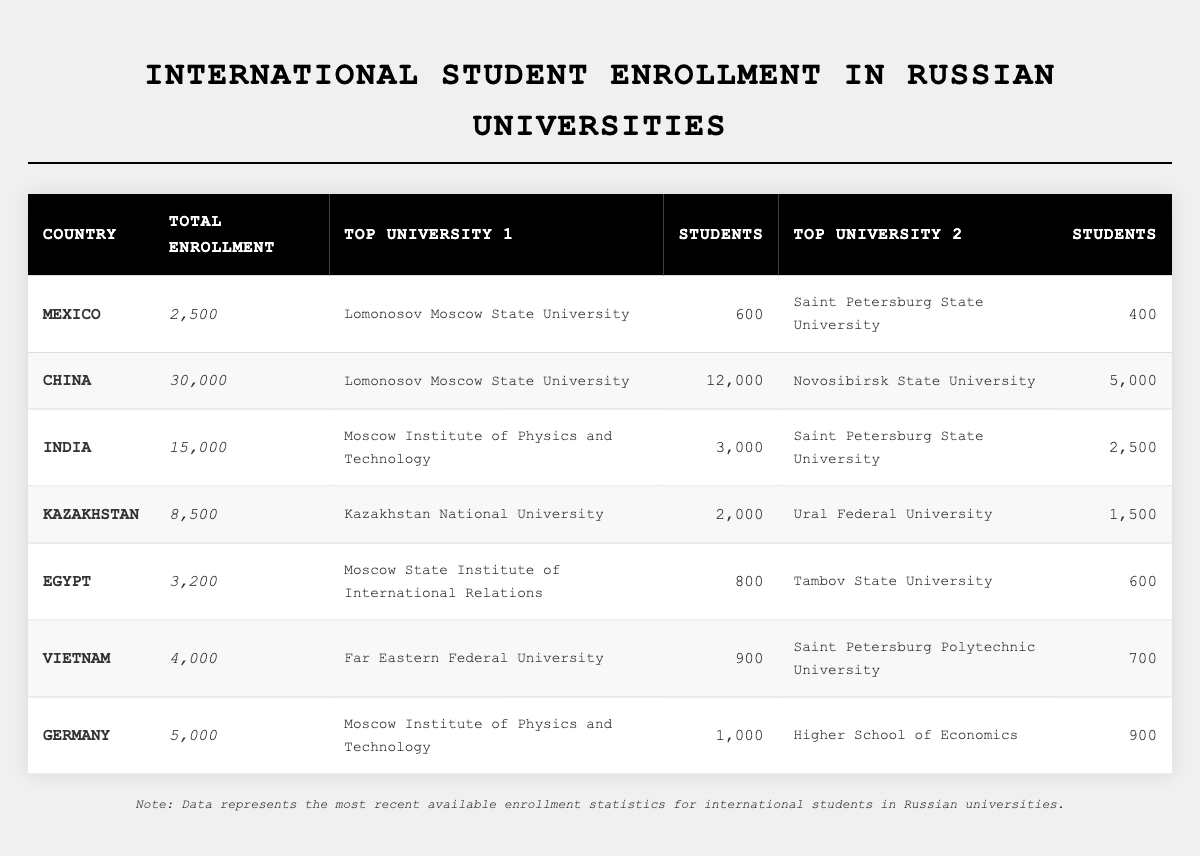What country has the highest number of international students enrolled in Russian universities? The table shows that China has the highest enrollment with 30,000 students.
Answer: China How many students are enrolled from Mexico? According to the table, Mexico has an enrollment of 2,500 international students.
Answer: 2,500 Which two universities enroll the most students from India? The top two universities for Indian students are Moscow Institute of Physics and Technology with 3,000 students and Saint Petersburg State University with 2,500 students.
Answer: Moscow Institute of Physics and Technology, Saint Petersburg State University What is the total number of international students enrolled from Egypt and Vietnam combined? The total enrollment for Egypt is 3,200 and for Vietnam is 4,000. Adding these gives 3,200 + 4,000 = 7,200.
Answer: 7,200 Is there a university that has more than 10,000 international students enrolled? Yes, Lomonosov Moscow State University has 12,000 students from China, which is more than 10,000.
Answer: Yes What is the average enrollment number for the countries listed in the table? Summing all enrollments gives 2,500 (Mexico) + 30,000 (China) + 15,000 (India) + 8,500 (Kazakhstan) + 3,200 (Egypt) + 4,000 (Vietnam) + 5,000 (Germany) = 68,200. Dividing by the 7 countries gives an average of 68,200 / 7 = 9,742.857, approximately 9,743.
Answer: 9,743 Which country has more students enrolled in Russian universities, Kazakhstan or Germany? Kazakhstan has 8,500 students enrolled while Germany has 5,000. So, Kazakhstan has more students.
Answer: Kazakhstan What percentage of Mexican students are enrolled in Lomonosov Moscow State University? There are 600 students enrolled in Lomonosov Moscow State University from Mexico out of 2,500 total students. The percentage is (600 / 2,500) * 100 = 24%.
Answer: 24% How many total students are enrolled in the top universities from China? The top two universities from China are Lomonosov Moscow State University with 12,000 students and Novosibirsk State University with 5,000. The total is 12,000 + 5,000 = 17,000.
Answer: 17,000 Which country has the least number of international students enrolled, based on the data provided? According to the table, Egypt has the least enrollment with 3,200 students.
Answer: Egypt What is the difference in total enrollment between students from India and students from Germany? India has 15,000 students enrolled, and Germany has 5,000. The difference is 15,000 - 5,000 = 10,000.
Answer: 10,000 